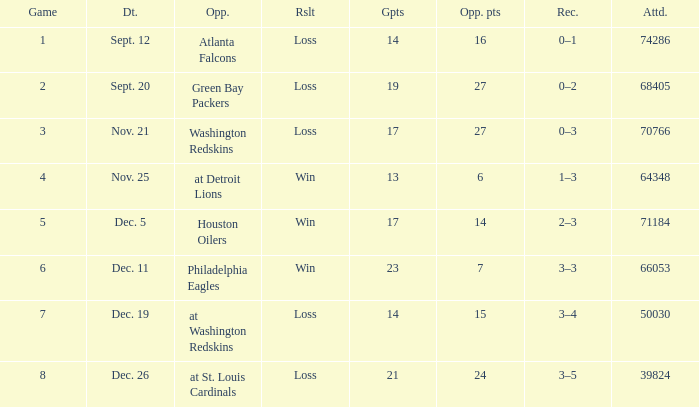What is the minimum number of opponents? 6.0. 